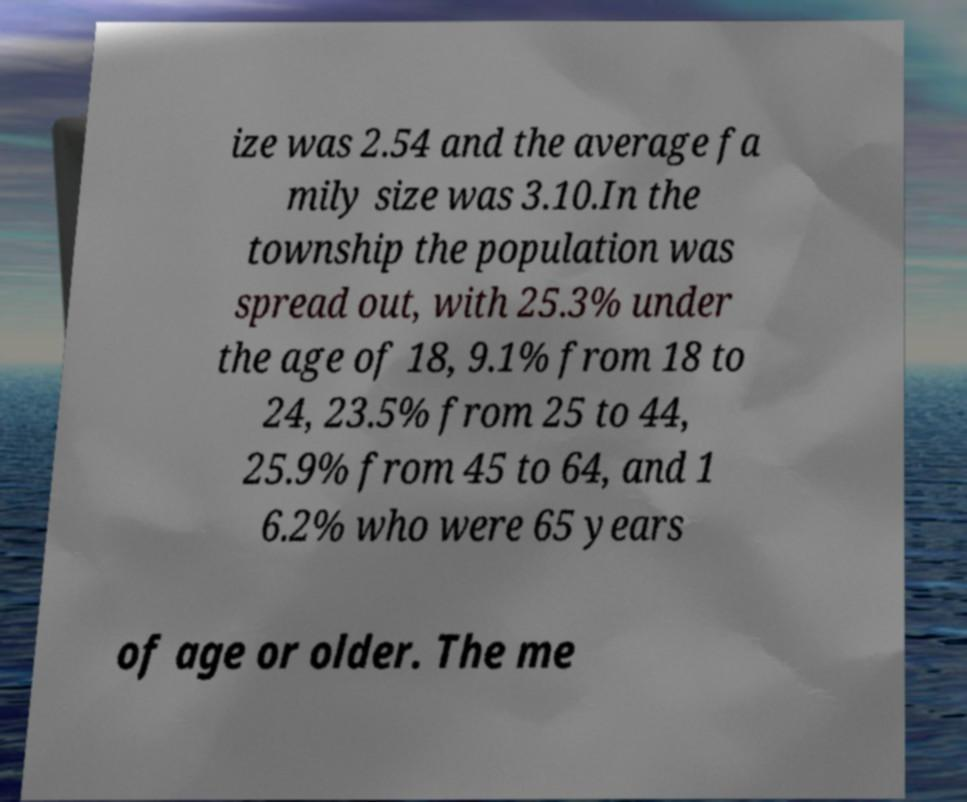What messages or text are displayed in this image? I need them in a readable, typed format. ize was 2.54 and the average fa mily size was 3.10.In the township the population was spread out, with 25.3% under the age of 18, 9.1% from 18 to 24, 23.5% from 25 to 44, 25.9% from 45 to 64, and 1 6.2% who were 65 years of age or older. The me 